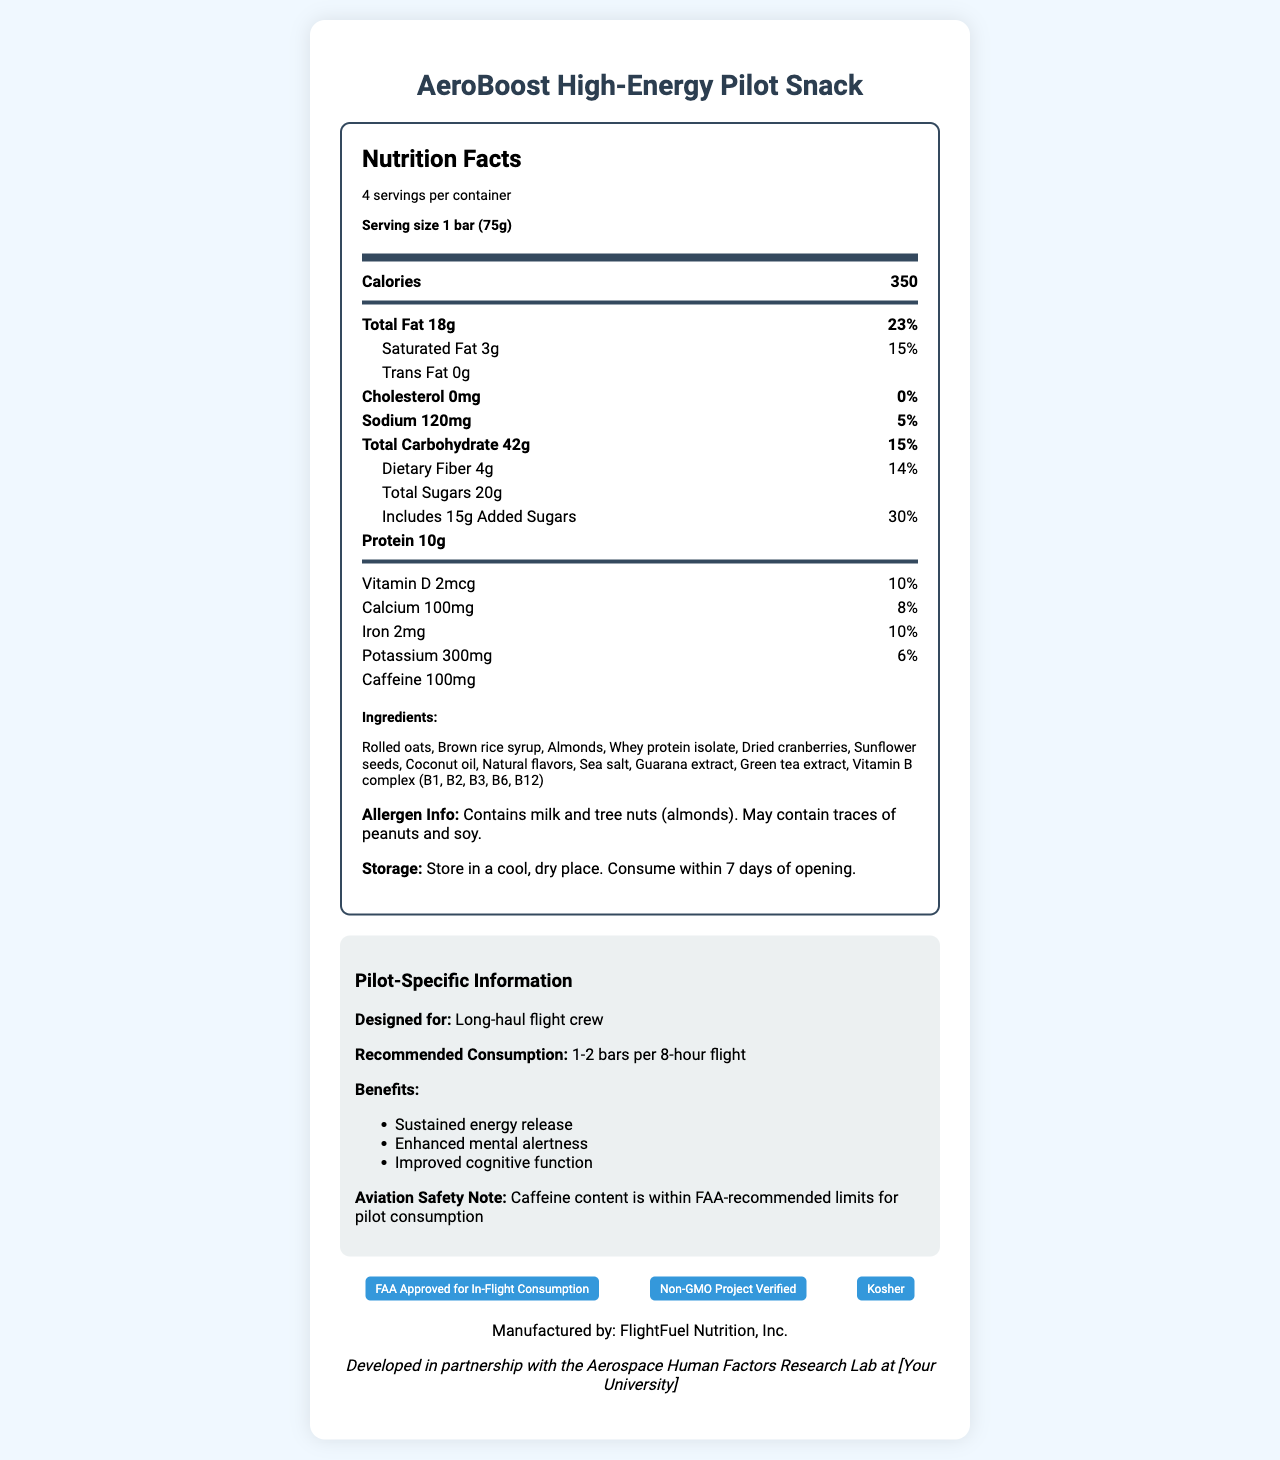what is the serving size of the AeroBoost High-Energy Pilot Snack? The serving size is stated in the document as "1 bar (75g)" under the Nutrition Facts.
Answer: 1 bar (75g) how many calories are there per serving? The document clearly mentions "Calories 350" in the Nutrition Facts section.
Answer: 350 what is the recommended consumption for long-haul flight crew? In the pilot-specific information section, it's recommended to consume "1-2 bars per 8-hour flight".
Answer: 1-2 bars per 8-hour flight what are the total fat and its daily value percentage per serving? The total fat amount and daily value are listed as "Total Fat 18g" and "23%" respectively.
Answer: 18g, 23% how much caffeine does each bar contain? In the Nutrition Facts section, it states "Caffeine 100mg".
Answer: 100mg which certification does the snack have? A. FAA Approved B. Organic C. Gluten-Free D. Fair Trade Certified The certification section mentions "FAA Approved for In-Flight Consumption".
Answer: A. FAA Approved how much sodium is present in one serving and what percentage of the daily value does it represent? A. 60mg, 3% B. 120mg, 5% C. 240mg, 10% The sodium content and daily value are detailed in the document as "Sodium 120mg" and "5%".
Answer: B. 120mg, 5% does the snack contain any allergens? The allergen information specifies that it "Contains milk and tree nuts (almonds). May contain traces of peanuts and soy."
Answer: Yes is trans fat present in the AeroBoost High-Energy Pilot Snack? The document lists "Trans Fat 0g", indicating there is no trans fat.
Answer: No summarize the main idea of the document. The summary covers the purpose and content of the document including nutritional details, specific benefits for pilots, and certifications.
Answer: The document is a Nutrition Facts label for the AeroBoost High-Energy Pilot Snack, designed specifically for long-haul flight crews. It outlines the nutritional content per serving, ingredients, allergens, storage instructions, certifications, and specific benefits for pilots. The snack includes sustained energy release and enhanced mental alertness while adhering to FAA-recommended caffeine limits. what are the main benefits of the AeroBoost High-Energy Pilot Snack for pilots? The pilot-specific information section lists these benefits explicitly.
Answer: Sustained energy release, Enhanced mental alertness, Improved cognitive function what is FlightFuel Nutrition, Inc.'s role in producing the AeroBoost snack? The document states that the snack is manufactured by FlightFuel Nutrition, Inc.
Answer: Manufacturer can the precise formulation of the Vitamin B complex be found in the document? The document mentions "Vitamin B complex (B1, B2, B3, B6, B12)" but does not provide the precise formulation or quantities.
Answer: Not enough information what should be done if the snack is opened and not consumed immediately? Under storage instructions, the document advises to "Store in a cool, dry place. Consume within 7 days of opening."
Answer: Store in a cool, dry place. Consume within 7 days of opening. who contributed to the research collaboration for developing this snack? In the document, it mentions a collaboration with "the Aerospace Human Factors Research Lab at [Your University]".
Answer: Aerospace Human Factors Research Lab at [Your University] how many servings are there per container? The document lists "4 servings per container" under Nutrition Facts.
Answer: 4 